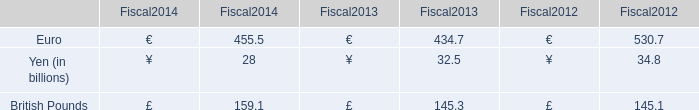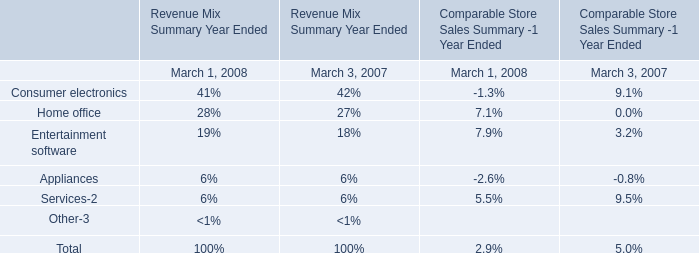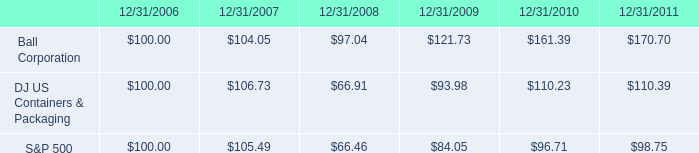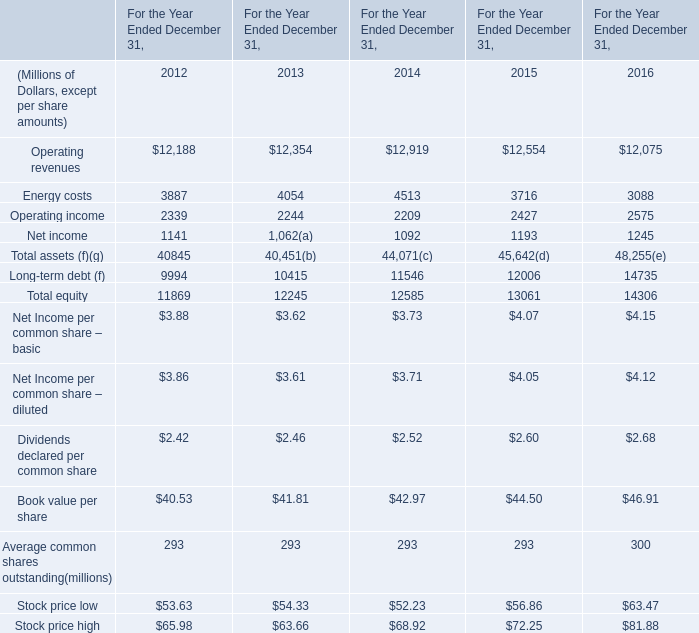what is the roi of an investment in dj us containers & packaging from 2006 to 2008? 
Computations: ((66.91 - 100) / 100)
Answer: -0.3309. 